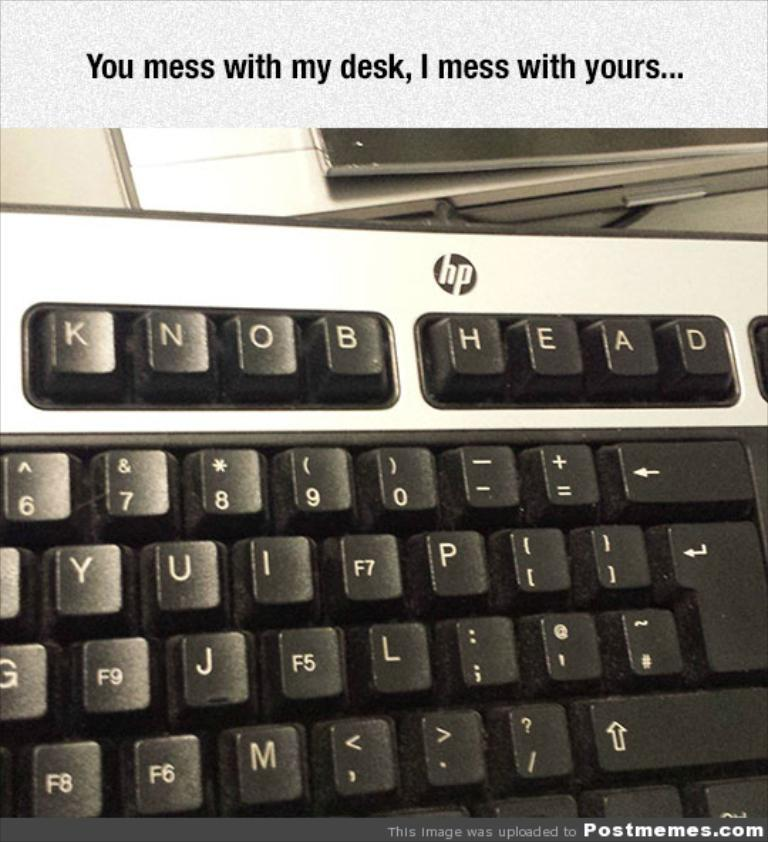<image>
Give a short and clear explanation of the subsequent image. As payback, his coworker changed the keys on his hp keyboard to read knob head!. 